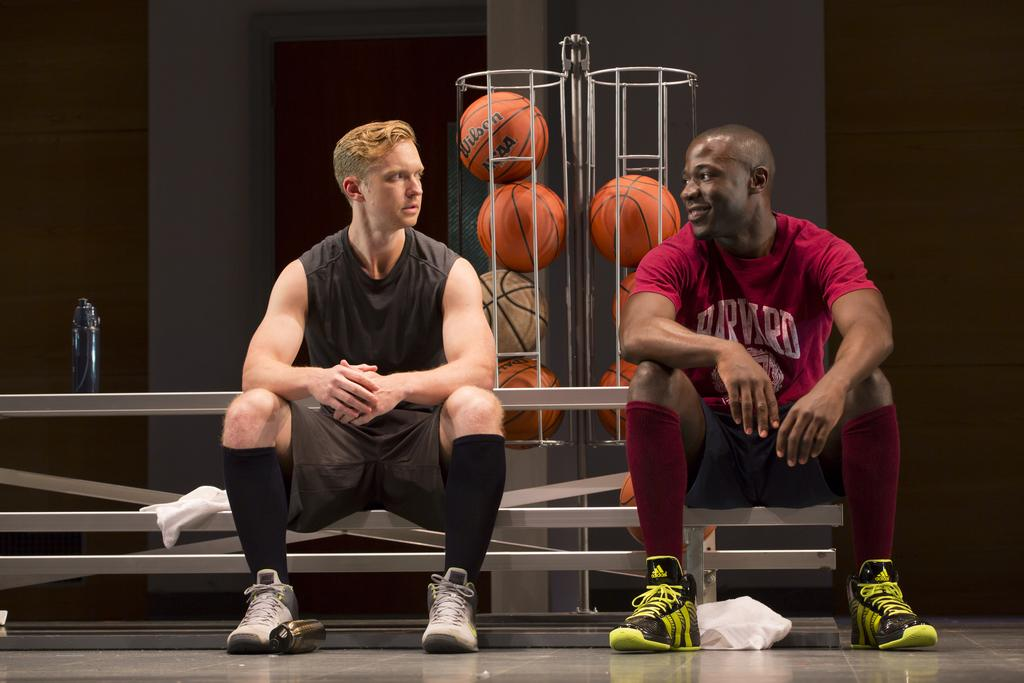What type of view is shown in the image? The image shows the inner view of a building. Can you describe the people in the image? There are two men sitting in the image. What objects can be seen on a surface in the image? There are objects on a surface in the image, including a water bottle. What type of objects are present in the image? There are balls in the image. What color is the wall in the image? There is a cream-colored wall in the image. How many mice are balancing on the lawyer's head in the image? There are no mice or lawyers present in the image. 